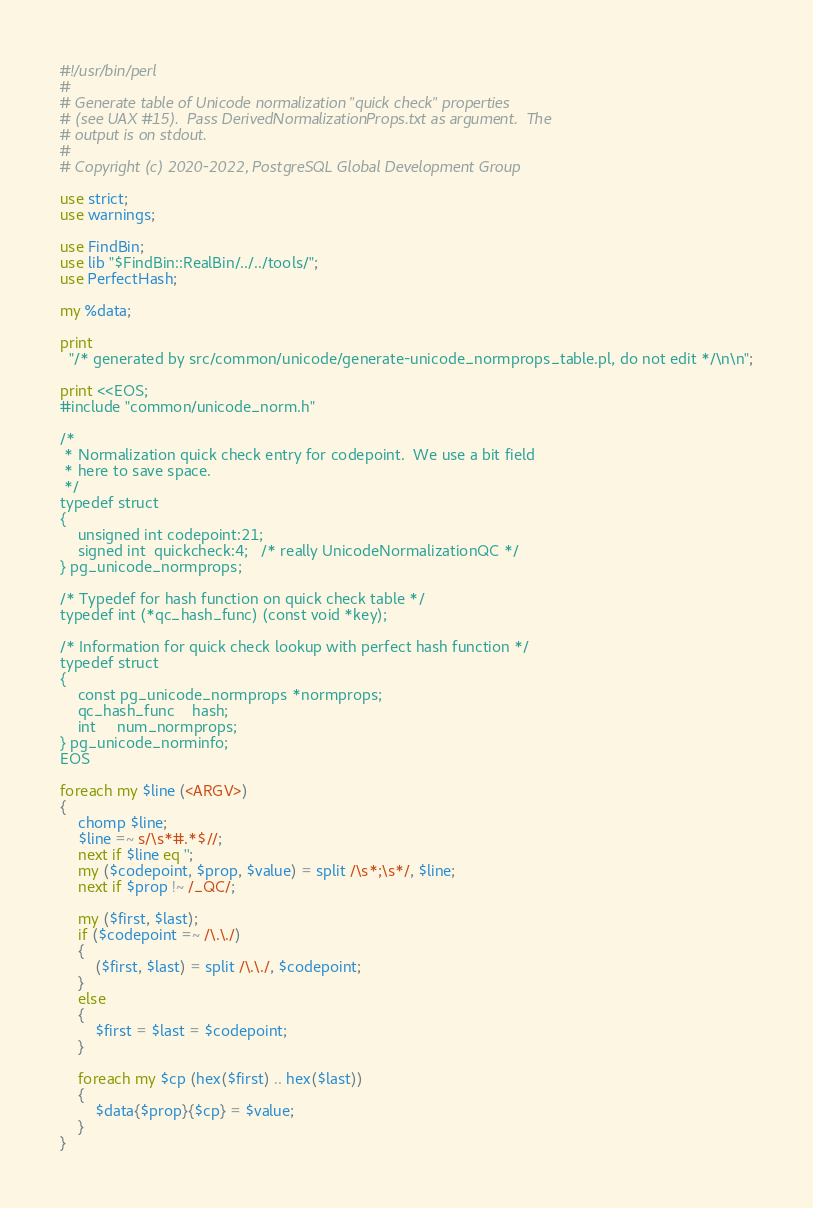Convert code to text. <code><loc_0><loc_0><loc_500><loc_500><_Perl_>#!/usr/bin/perl
#
# Generate table of Unicode normalization "quick check" properties
# (see UAX #15).  Pass DerivedNormalizationProps.txt as argument.  The
# output is on stdout.
#
# Copyright (c) 2020-2022, PostgreSQL Global Development Group

use strict;
use warnings;

use FindBin;
use lib "$FindBin::RealBin/../../tools/";
use PerfectHash;

my %data;

print
  "/* generated by src/common/unicode/generate-unicode_normprops_table.pl, do not edit */\n\n";

print <<EOS;
#include "common/unicode_norm.h"

/*
 * Normalization quick check entry for codepoint.  We use a bit field
 * here to save space.
 */
typedef struct
{
	unsigned int codepoint:21;
	signed int	quickcheck:4;	/* really UnicodeNormalizationQC */
} pg_unicode_normprops;

/* Typedef for hash function on quick check table */
typedef int (*qc_hash_func) (const void *key);

/* Information for quick check lookup with perfect hash function */
typedef struct
{
	const pg_unicode_normprops *normprops;
	qc_hash_func	hash;
	int		num_normprops;
} pg_unicode_norminfo;
EOS

foreach my $line (<ARGV>)
{
	chomp $line;
	$line =~ s/\s*#.*$//;
	next if $line eq '';
	my ($codepoint, $prop, $value) = split /\s*;\s*/, $line;
	next if $prop !~ /_QC/;

	my ($first, $last);
	if ($codepoint =~ /\.\./)
	{
		($first, $last) = split /\.\./, $codepoint;
	}
	else
	{
		$first = $last = $codepoint;
	}

	foreach my $cp (hex($first) .. hex($last))
	{
		$data{$prop}{$cp} = $value;
	}
}
</code> 